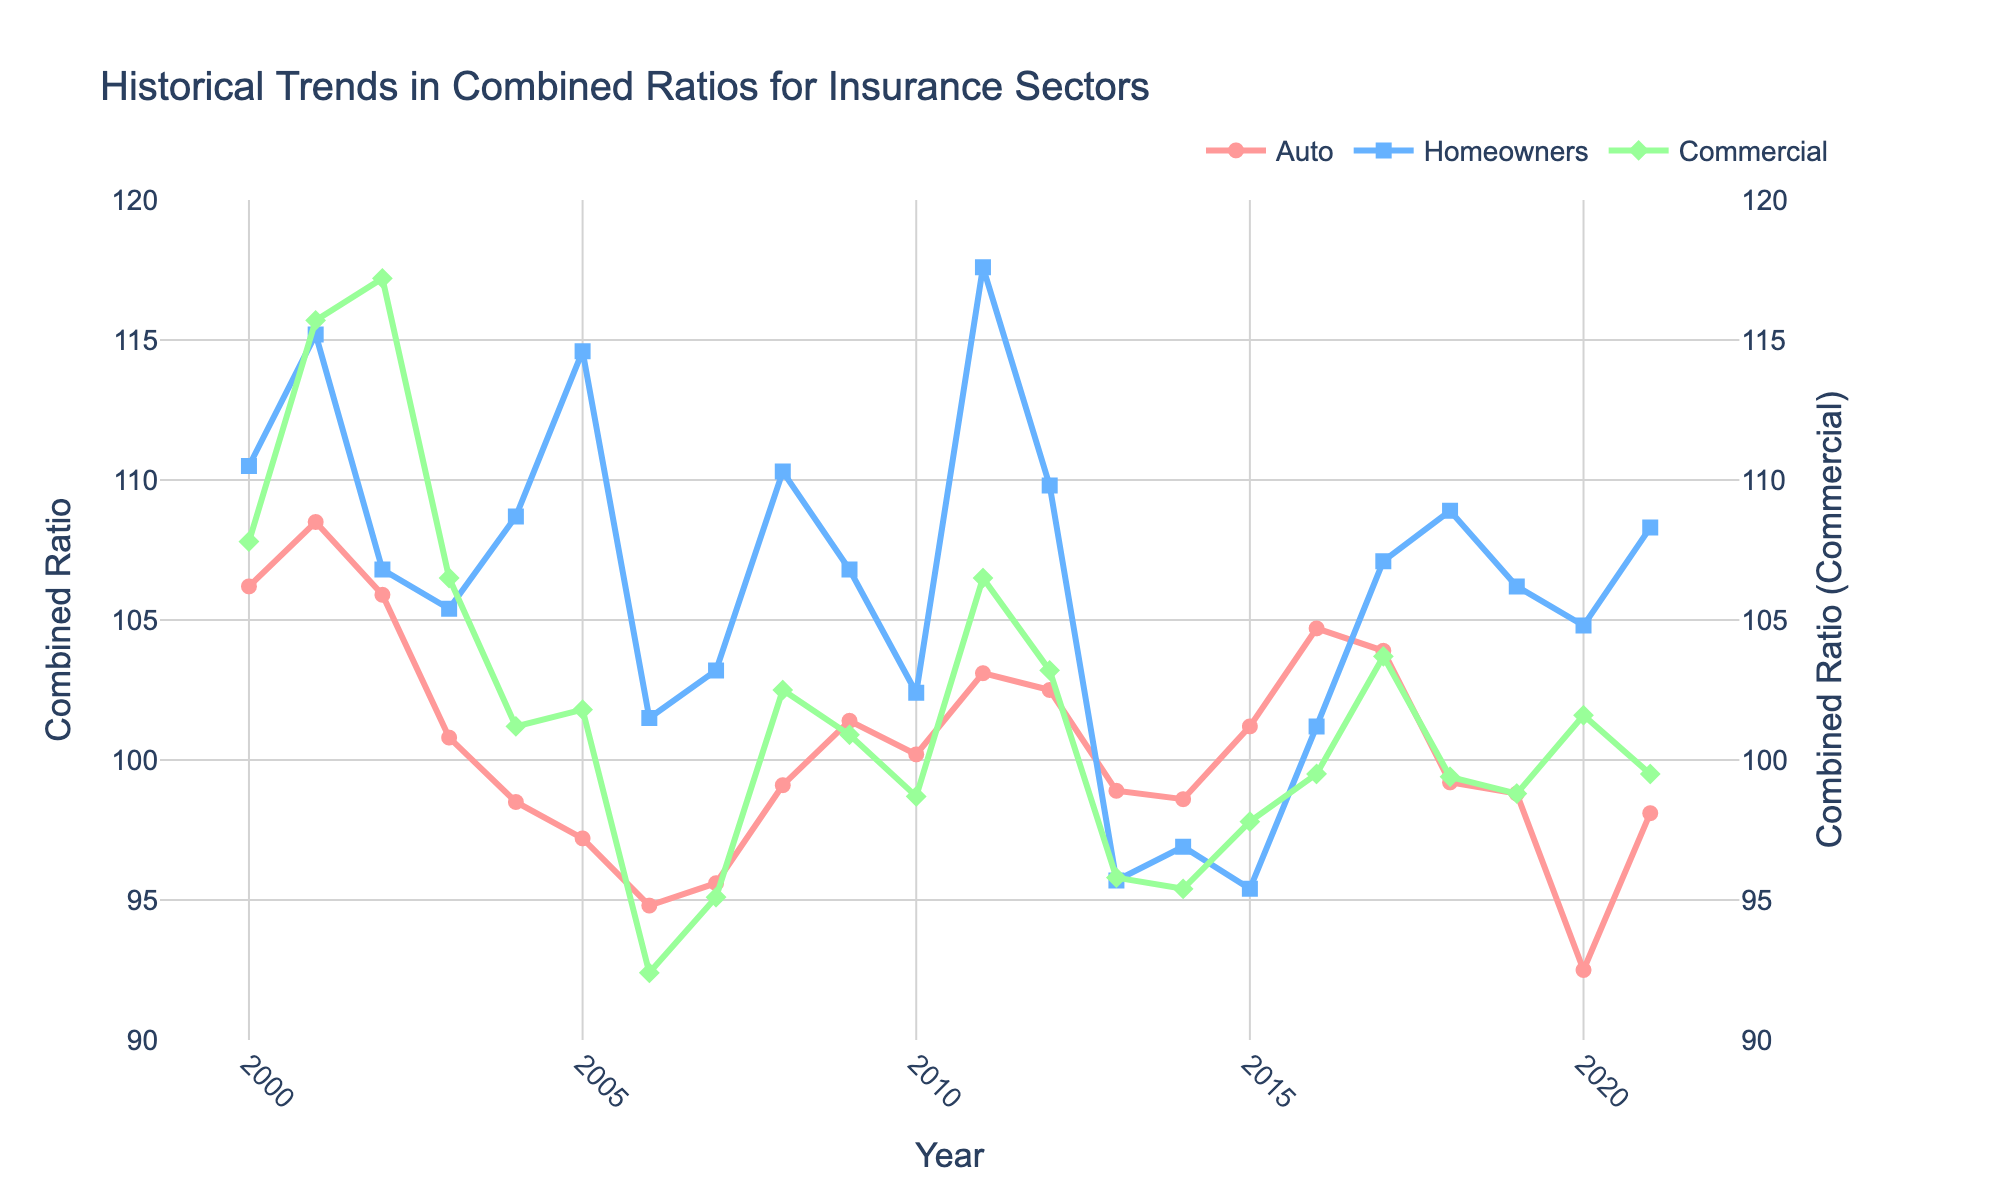What's the trend for auto insurance combined ratios from 2000 to 2021? To determine the trend for auto insurance combined ratios, observe the 'Auto' line on the chart. It starts high in 2000 (~106.2) and shows fluctuations but generally trends downwards, finishing at 98.1 in 2021.
Answer: Downward trend How did homeowners insurance combined ratios fluctuate between 2000 and 2021? To understand the fluctuations in homeowners insurance combined ratios, follow the 'Homeowners' line. It starts high in 2000 (~110.5), peaks around 2001 (~115.2) and again in 2011 (~117.6), then experiences a noticeable drop around 2013 (~95.7), ending around 108.3 in 2021.
Answer: Significant fluctuations with peaks and drops Which insurance sector had the lowest combined ratio in 2006? Look for the lowest point on each of the three lines in 2006. The 'Auto' line is at approximately 94.8, 'Homeowners' at around 101.5, and 'Commercial' at around 92.4. The 'Commercial' line has the lowest value.
Answer: Commercial How did the commercial insurance combined ratio change between 2005 and 2006? To find this change, observe the 'Commercial' line between these years. It drops from around 101.8 in 2005 to about 92.4 in 2006, indicating a decrease.
Answer: Decreased Comparing the endpoints, which sector exhibits the greatest improvement in combined ratio from 2000 to 2021? Compare the combined ratios for 2000 and 2021 for each sector. 'Auto' drops from 106.2 to 98.1, 'Homeowners' from 110.5 to 108.3, and 'Commercial' from 107.8 to 99.5. 'Commercial' exhibits the greatest improvement.
Answer: Commercial What was the average combined ratio for auto insurance over 2010 to 2012? Average the 'Auto' values for 2010 (100.2), 2011 (103.1), and 2012 (102.5). Calculation: (100.2 + 103.1 + 102.5) / 3 ≈ 101.93.
Answer: 101.93 What year did the homeowners insurance sector have the smallest combined ratio, and what was the value? Trace the 'Homeowners' line to find its lowest point, which occurs in 2013, with a value of approximately 95.7.
Answer: 2013, 95.7 Which sectors had combined ratios below 100 in 2014? Check the combined ratio values for each line in 2014. 'Auto' is 98.6, 'Homeowners' is 96.9, 'Commercial' is 95.4 – all below 100.
Answer: Auto, Homeowners, Commercial From the visual, which insurance sector has the most volatile combined ratio over the years shown? Observe all three lines for volatility. The 'Homeowners' line shows numerous peaks and troughs compared to 'Auto' and 'Commercial'.
Answer: Homeowners What improvement in auto insurance combined ratio can be seen from 2001 to 2013? Find 'Auto' values for 2001 (108.5) and 2013 (98.9). Calculate the difference: 108.5 - 98.9 = 9.6
Answer: 9.6 